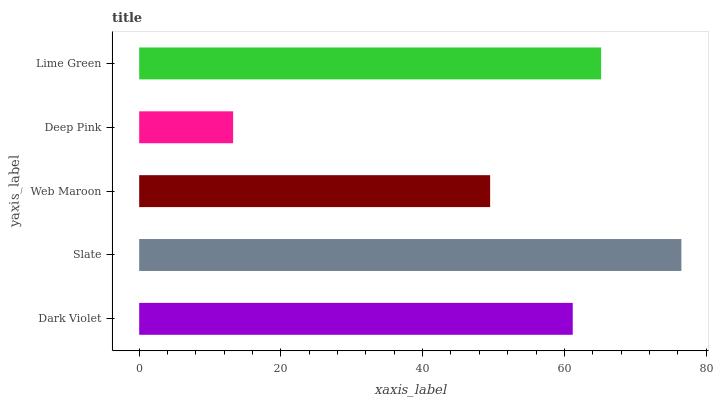Is Deep Pink the minimum?
Answer yes or no. Yes. Is Slate the maximum?
Answer yes or no. Yes. Is Web Maroon the minimum?
Answer yes or no. No. Is Web Maroon the maximum?
Answer yes or no. No. Is Slate greater than Web Maroon?
Answer yes or no. Yes. Is Web Maroon less than Slate?
Answer yes or no. Yes. Is Web Maroon greater than Slate?
Answer yes or no. No. Is Slate less than Web Maroon?
Answer yes or no. No. Is Dark Violet the high median?
Answer yes or no. Yes. Is Dark Violet the low median?
Answer yes or no. Yes. Is Deep Pink the high median?
Answer yes or no. No. Is Slate the low median?
Answer yes or no. No. 